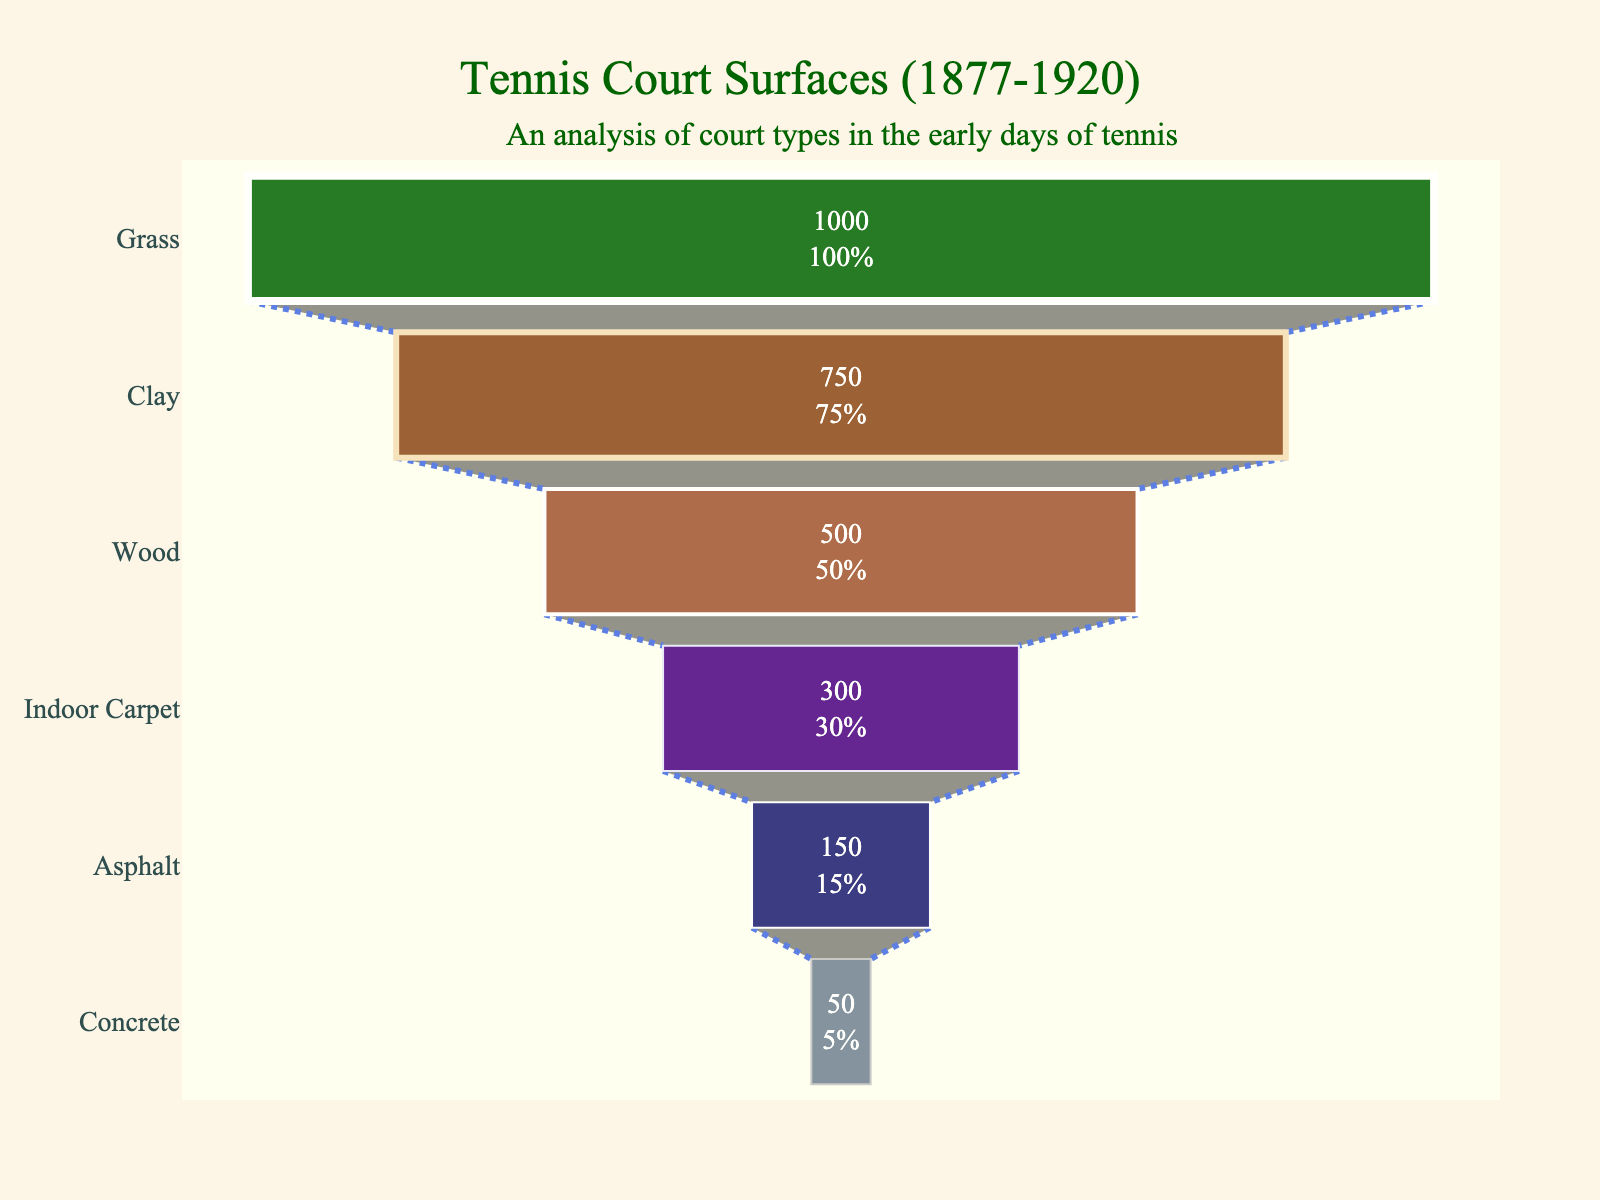Which surface type has the highest number of courts? The funnel chart shows that the surface type with the highest number of courts is positioned at the top of the chart, and the figure indicates it as Grass with 1000 courts.
Answer: Grass How many courts are there in total? Sum the number of courts for each surface type: 1000 (Grass) + 750 (Clay) + 500 (Wood) + 300 (Indoor Carpet) + 150 (Asphalt) + 50 (Concrete) = 2750.
Answer: 2750 Which surface type had the least number of courts, and what was the count? The bottom of the funnel chart shows the surface type with the fewest courts, and the figure indicates it as Concrete with 50 courts.
Answer: Concrete, 50 By what percentage did the number of clay courts differ from wood courts? Calculate the difference in number and then find the percentage: (750 - 500) / 750 * 100 = 33.33%.
Answer: 33.33% How many more grass courts were there compared to indoor carpet courts? Subtract the number of indoor carpet courts from the number of grass courts: 1000 - 300 = 700.
Answer: 700 What does each segment of the funnel chart represent? Each segment represents a different type of tennis court surface, with the width of each segment indicating the number of courts of that surface type.
Answer: Different court surfaces What is the ratio of grass courts to concrete courts? Divide the number of grass courts by the number of concrete courts: 1000 / 50 = 20.
Answer: 20 What percentage of the total courts were wood courts? Calculate the percentage using the total number of courts: (500 / 2750) * 100 ≈ 18.18%.
Answer: 18.18% How does the number of asphalt courts compare to clay courts? The figure shows 150 asphalt courts and 750 clay courts. The number of asphalt courts is 600 less than the number of clay courts.
Answer: 600 less What insight does the funnel chart provide about tennis court surfaces from 1877 to 1920? The funnel chart illustrates the prevalence of different tennis court surfaces used during this period, highlighting that grass courts were the most common, while concrete courts were the least used.
Answer: Grass most common, concrete least used 